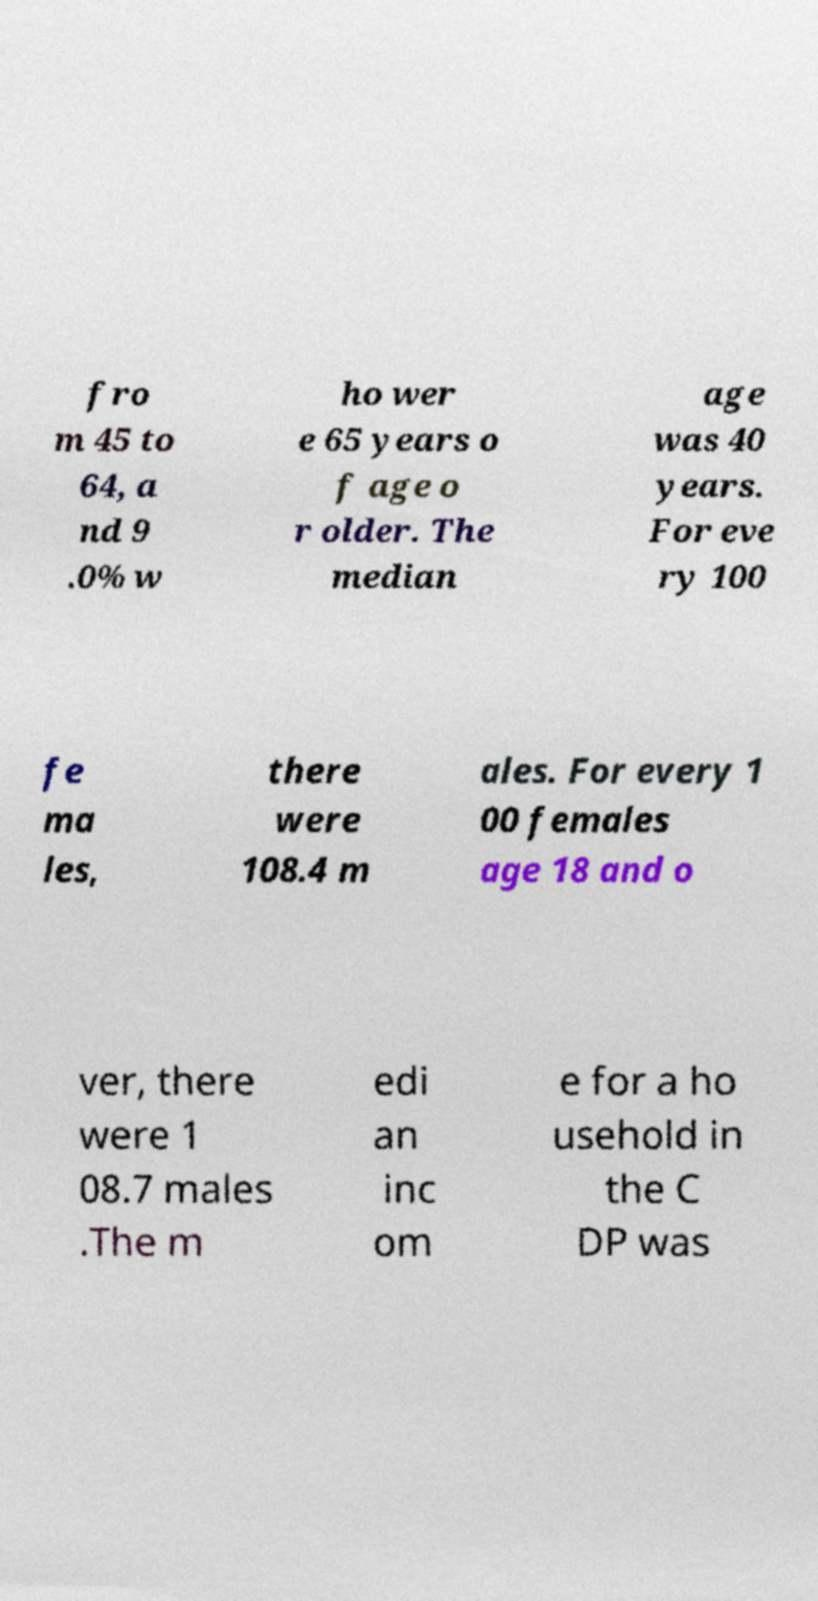Can you read and provide the text displayed in the image?This photo seems to have some interesting text. Can you extract and type it out for me? fro m 45 to 64, a nd 9 .0% w ho wer e 65 years o f age o r older. The median age was 40 years. For eve ry 100 fe ma les, there were 108.4 m ales. For every 1 00 females age 18 and o ver, there were 1 08.7 males .The m edi an inc om e for a ho usehold in the C DP was 